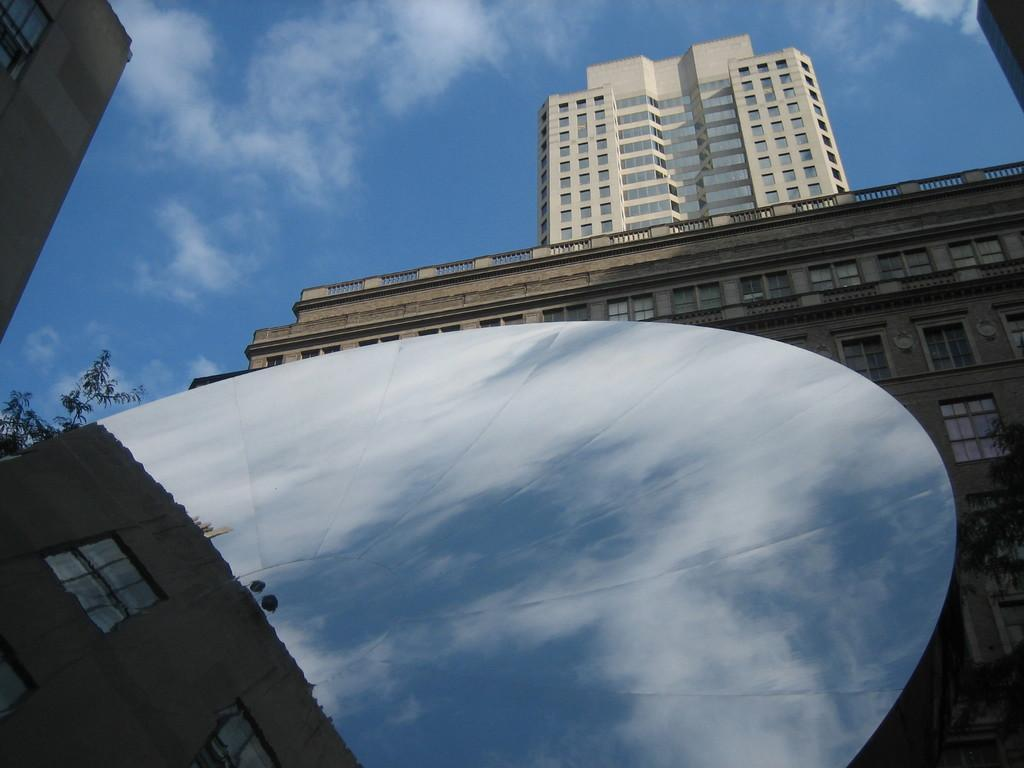What type of structures are present in the image? There are buildings with windows in the image. Can you describe the white object in the image? There is a white color object in the image, but its specific nature is not clear from the facts provided. What type of vegetation is present in the image? There are trees in the image. What can be seen in the background of the image? The sky with clouds is visible in the background of the image. What type of art is being created by the bells in the image? There are no bells present in the image, so it is not possible to answer that question. 